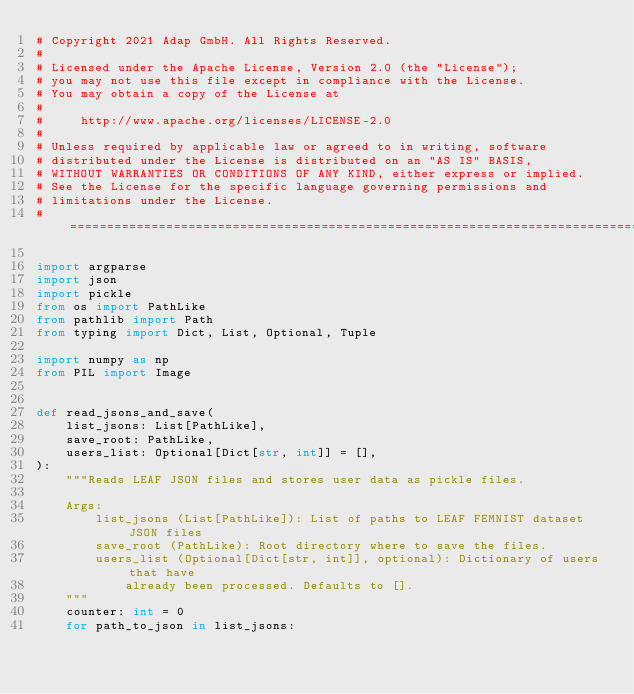Convert code to text. <code><loc_0><loc_0><loc_500><loc_500><_Python_># Copyright 2021 Adap GmbH. All Rights Reserved.
#
# Licensed under the Apache License, Version 2.0 (the "License");
# you may not use this file except in compliance with the License.
# You may obtain a copy of the License at
#
#     http://www.apache.org/licenses/LICENSE-2.0
#
# Unless required by applicable law or agreed to in writing, software
# distributed under the License is distributed on an "AS IS" BASIS,
# WITHOUT WARRANTIES OR CONDITIONS OF ANY KIND, either express or implied.
# See the License for the specific language governing permissions and
# limitations under the License.
# ==============================================================================

import argparse
import json
import pickle
from os import PathLike
from pathlib import Path
from typing import Dict, List, Optional, Tuple

import numpy as np
from PIL import Image


def read_jsons_and_save(
    list_jsons: List[PathLike],
    save_root: PathLike,
    users_list: Optional[Dict[str, int]] = [],
):
    """Reads LEAF JSON files and stores user data as pickle files.

    Args:
        list_jsons (List[PathLike]): List of paths to LEAF FEMNIST dataset JSON files
        save_root (PathLike): Root directory where to save the files.
        users_list (Optional[Dict[str, int]], optional): Dictionary of users that have
            already been processed. Defaults to [].
    """
    counter: int = 0
    for path_to_json in list_jsons:</code> 